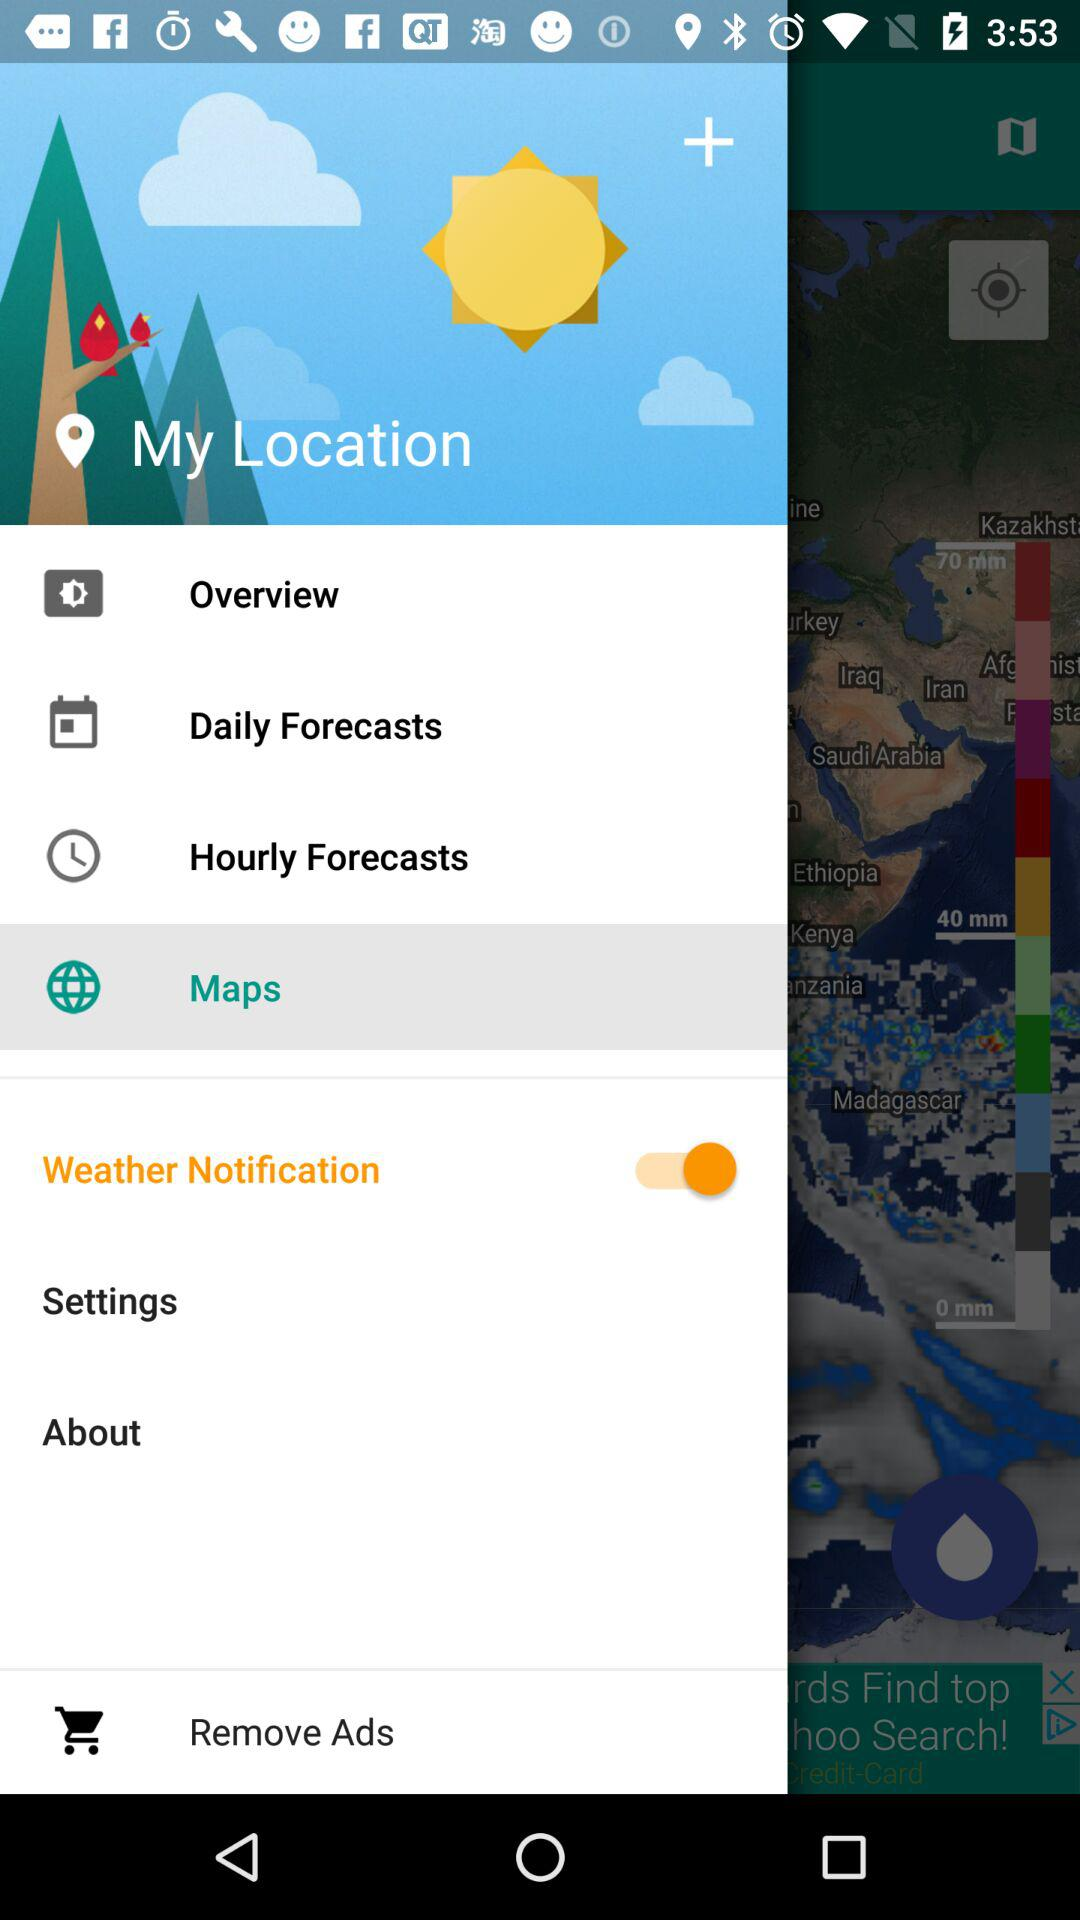Which item is currently selected? The currently selected item is "Maps". 